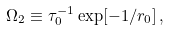Convert formula to latex. <formula><loc_0><loc_0><loc_500><loc_500>\Omega _ { 2 } \equiv \tau _ { 0 } ^ { - 1 } \exp [ - 1 / r _ { 0 } ] \, ,</formula> 